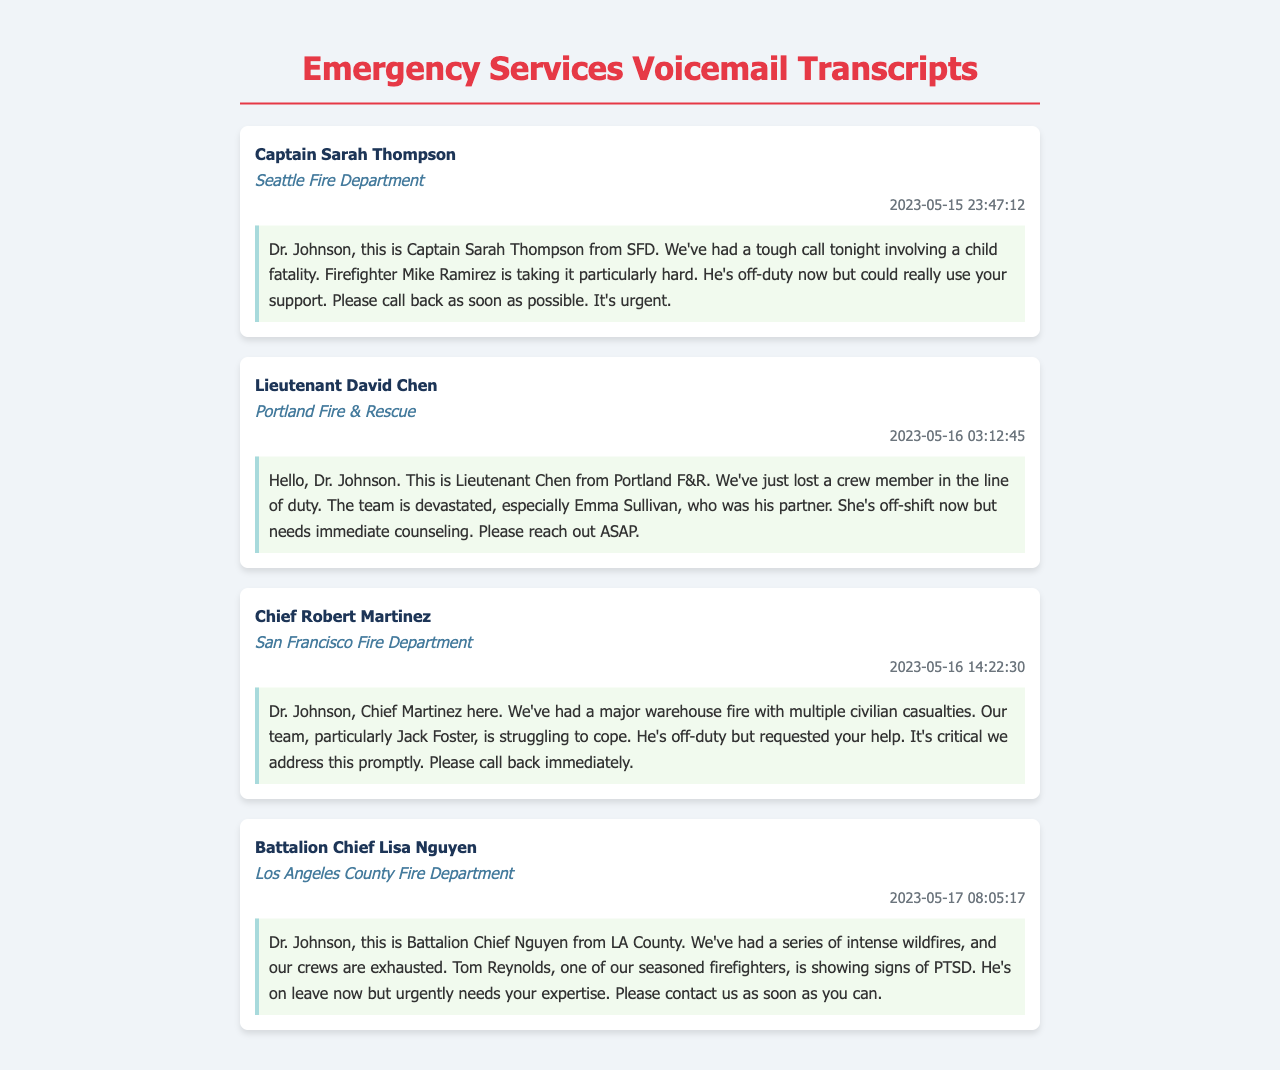What is the name of the caller from Seattle Fire Department? The caller from Seattle Fire Department is Captain Sarah Thompson.
Answer: Captain Sarah Thompson What date did Lieutenant David Chen leave a message? The message from Lieutenant David Chen was left on May 16, 2023.
Answer: May 16, 2023 Which firefighter is specifically mentioned as needing support after a fatal call? Firefighter Mike Ramirez is mentioned as needing support after the call involving a child fatality.
Answer: Mike Ramirez What incident impacted the crew member from Portland Fire & Rescue? The crew member from Portland Fire & Rescue lost his life in the line of duty.
Answer: lost a crew member Who is showing signs of PTSD in Los Angeles County Fire Department? Tom Reynolds is showing signs of PTSD in Los Angeles County Fire Department.
Answer: Tom Reynolds What is the urgency level for contacting the therapist as indicated in the transcripts? The urgency level is indicated as critical and immediate in all messages.
Answer: urgent How many transcripts are documented in total? There are four transcripts documented in total.
Answer: four What type of support is requested for firefighters in these messages? The requested support in these messages is counseling.
Answer: counseling 